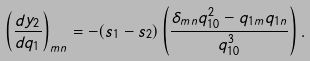Convert formula to latex. <formula><loc_0><loc_0><loc_500><loc_500>\left ( \frac { d y _ { 2 } } { d q _ { 1 } } \right ) _ { m n } = - ( s _ { 1 } - s _ { 2 } ) \left ( \frac { \delta _ { m n } q _ { 1 0 } ^ { 2 } - q _ { 1 m } q _ { 1 n } } { q _ { 1 0 } ^ { 3 } } \right ) .</formula> 